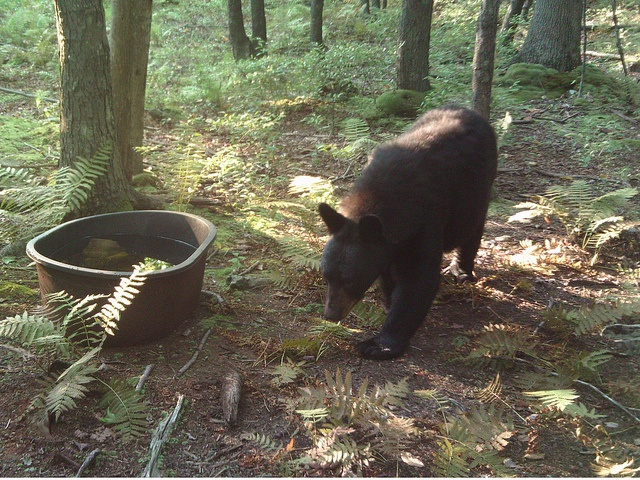Describe the objects in this image and their specific colors. I can see bear in lightgreen, black, gray, and darkgray tones and bowl in lightgreen, black, and gray tones in this image. 